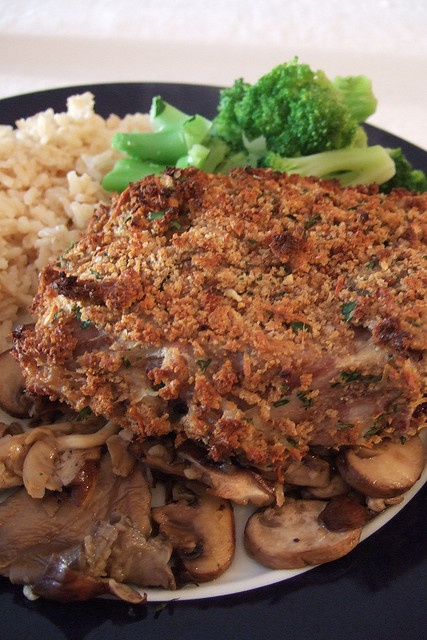Describe the objects in this image and their specific colors. I can see dining table in maroon, black, brown, and lightgray tones and broccoli in lightgray, darkgreen, green, and olive tones in this image. 